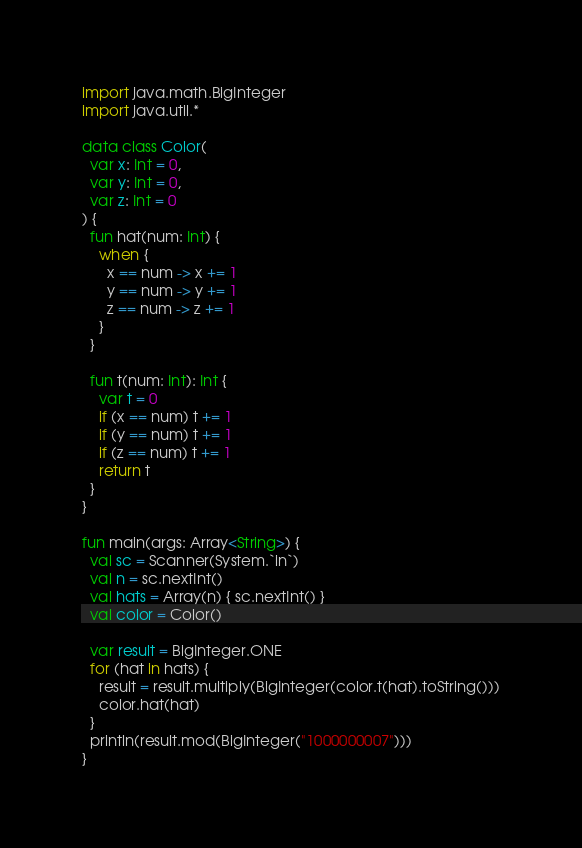Convert code to text. <code><loc_0><loc_0><loc_500><loc_500><_Kotlin_>import java.math.BigInteger
import java.util.*

data class Color(
  var x: Int = 0,
  var y: Int = 0,
  var z: Int = 0
) {
  fun hat(num: Int) {
    when {
      x == num -> x += 1
      y == num -> y += 1
      z == num -> z += 1
    }
  }

  fun t(num: Int): Int {
    var t = 0
    if (x == num) t += 1
    if (y == num) t += 1
    if (z == num) t += 1
    return t
  }
}

fun main(args: Array<String>) {
  val sc = Scanner(System.`in`)
  val n = sc.nextInt()
  val hats = Array(n) { sc.nextInt() }
  val color = Color()

  var result = BigInteger.ONE
  for (hat in hats) {
    result = result.multiply(BigInteger(color.t(hat).toString()))
    color.hat(hat)
  }
  println(result.mod(BigInteger("1000000007")))
}</code> 